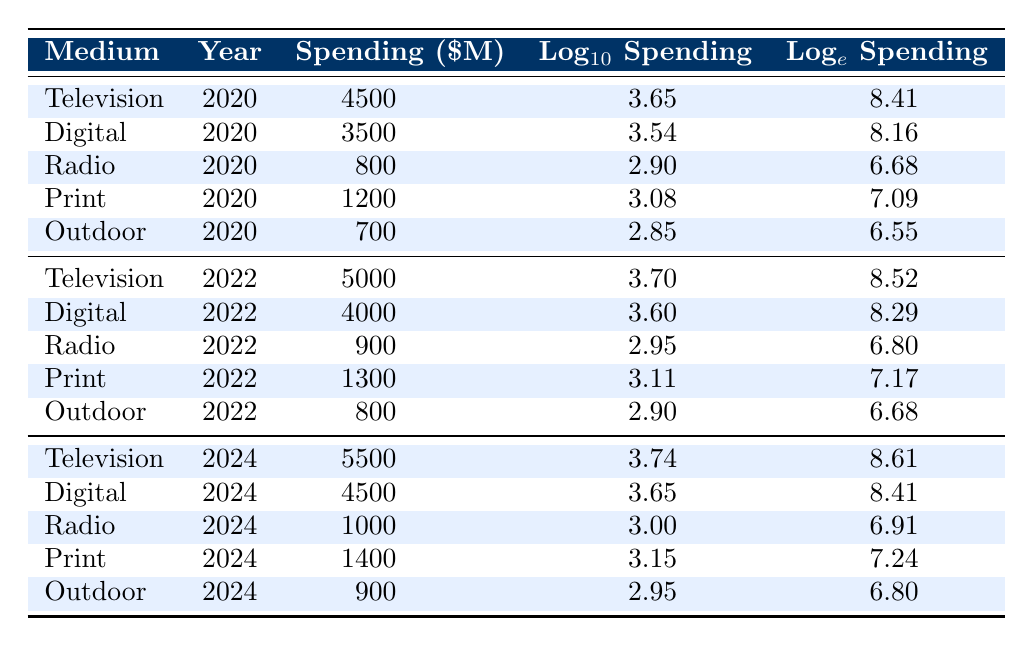What is the spending on Digital advertising in 2022? Looking at the row for Digital advertising in 2022, the spending listed is 4000 million dollars.
Answer: 4000 million dollars In which year did Print advertising spending first exceed 1200 million dollars? The spending for Print advertising in 2020 is 1200 million dollars, and it increases to 1300 million dollars in 2022 and 1400 million dollars in 2024, meaning the spending first surpassed 1200 million dollars in 2022.
Answer: 2022 Did Outdoor advertising spending increase from 2020 to 2024? The values for Outdoor spending are 700 million dollars in 2020, 800 million dollars in 2022, and 900 million dollars in 2024, indicating a clear increase in spending over the years.
Answer: Yes What is the difference between the spending on Television in 2024 and 2020? The spending for Television in 2024 is 5500 million dollars and in 2020 it is 4500 million dollars. The difference is calculated as 5500 - 4500 = 1000 million dollars.
Answer: 1000 million dollars What is the average spending on Radio across all three years? The spending values for Radio are 800 million (2020), 900 million (2022), and 1000 million (2024). To find the average, sum these up: 800 + 900 + 1000 = 2700 million dollars, then divide by 3: 2700 / 3 = 900 million dollars.
Answer: 900 million dollars In which year did Television advertising show the highest spending? Checking the values for Television, we find 4500 million in 2020, 5000 million in 2022, and 5500 million in 2024, showing that 2024 had the highest spending.
Answer: 2024 Is the logarithmic value of Digital spending higher in 2022 or 2024? The logarithmic values for Digital spending are 3.60 in 2022 and 3.65 in 2024. Since 3.65 is greater than 3.60, the logarithmic value is higher in 2024.
Answer: 2024 Which advertising medium had the lowest spending in 2020? Looking at the values for all mediums in 2020, Outdoor with 700 million dollars is the lowest compared to others (Television, Digital, Radio, and Print).
Answer: Outdoor How much more was spent on Digital advertising in 2024 compared to Radio advertising in the same year? The spending for Digital in 2024 is 4500 million dollars and for Radio in 2024 is 1000 million dollars. The difference is: 4500 - 1000 = 3500 million dollars.
Answer: 3500 million dollars 